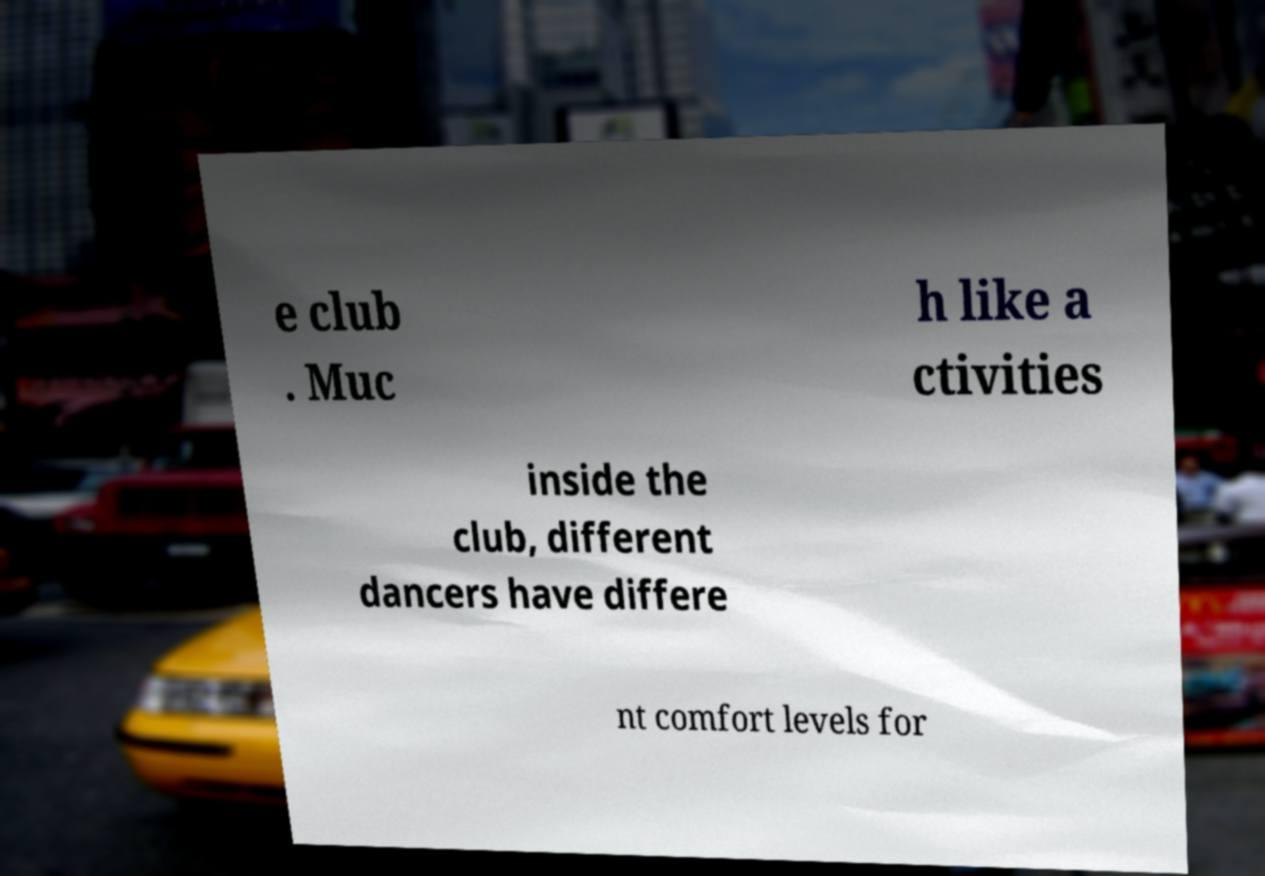Please read and relay the text visible in this image. What does it say? e club . Muc h like a ctivities inside the club, different dancers have differe nt comfort levels for 